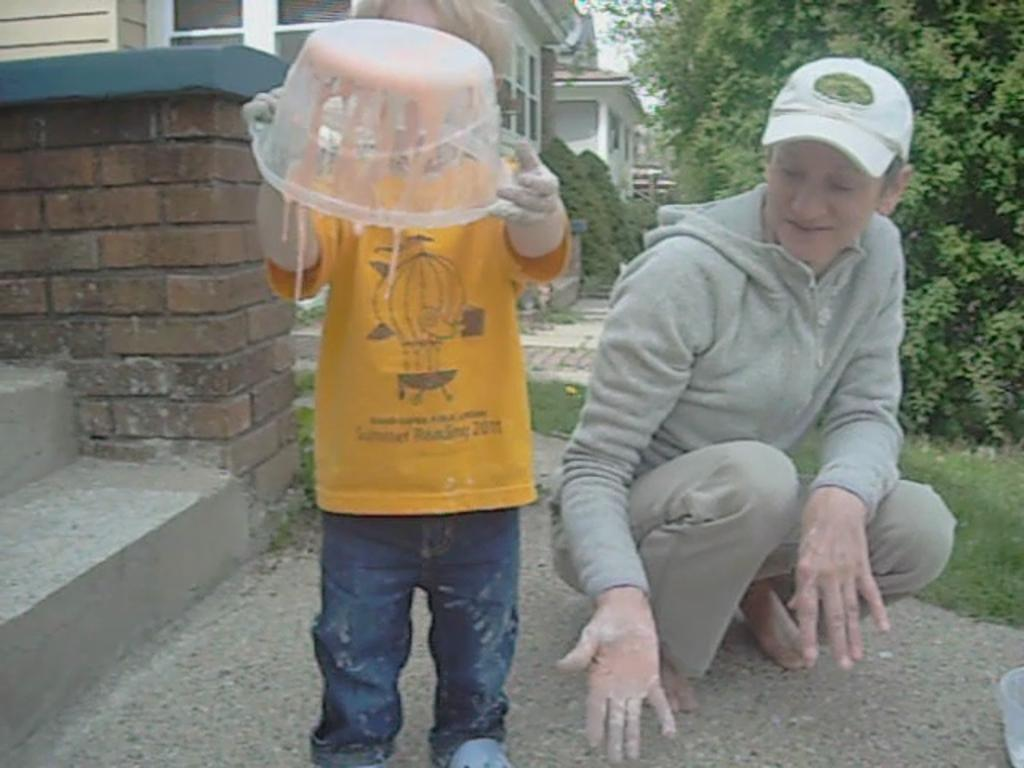What is the person in the image holding? The person is holding a tub in the image. What can be seen in the distance behind the person? There are houses, buildings, grass, and state cases in the background of the image. Can you see a kitten twisting its foot in the image? No, there is no kitten or any indication of twisting feet in the image. 